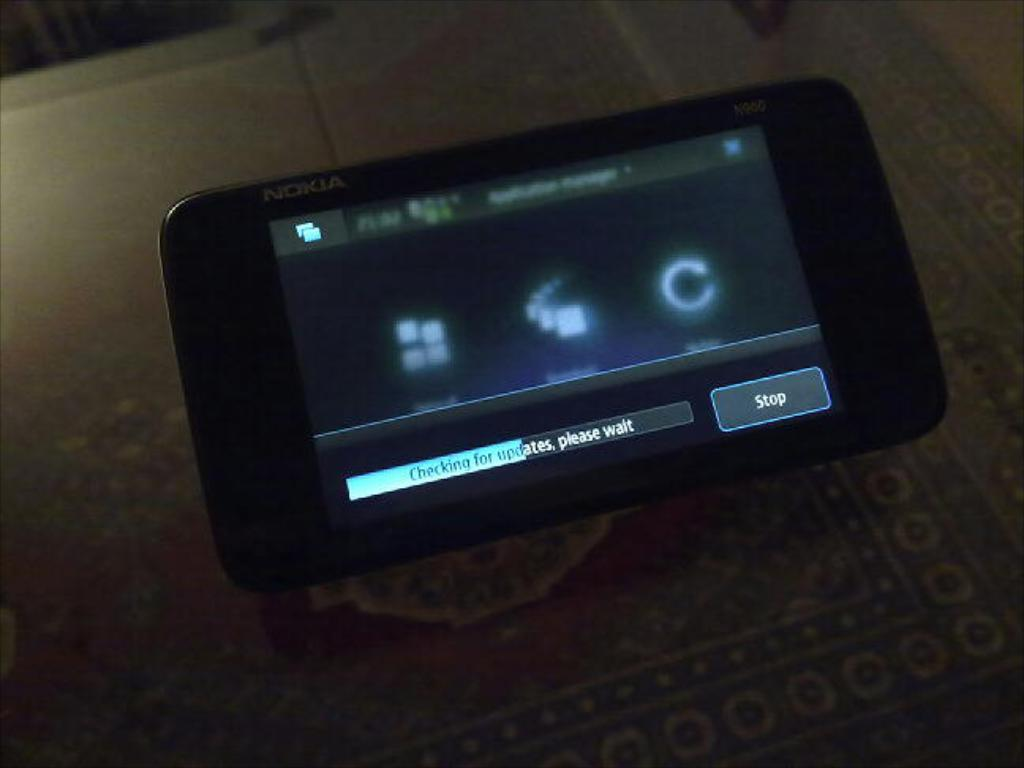<image>
Relay a brief, clear account of the picture shown. A black Nokia brand cellphone with a display screen that has a Stop tab 